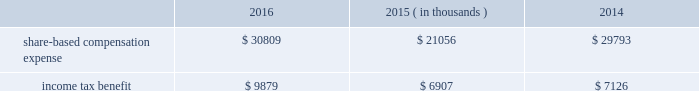2000 non-employee director stock option plan ( the 201cdirector stock option plan 201d ) , and the global payments inc .
2011 incentive plan ( the 201c2011 plan 201d ) ( collectively , the 201cplans 201d ) .
We made no further grants under the 2000 plan after the 2005 plan was effective , and the director stock option plan expired by its terms on february 1 , 2011 .
We will make no future grants under the 2000 plan , the 2005 plan or the director stock option plan .
The 2011 plan permits grants of equity to employees , officers , directors and consultants .
A total of 14.0 million shares of our common stock was reserved and made available for issuance pursuant to awards granted under the 2011 plan .
The table summarizes share-based compensation expense and the related income tax benefit recognized for our share-based awards and stock options ( in thousands ) : 2016 2015 2014 ( in thousands ) .
We grant various share-based awards pursuant to the plans under what we refer to as our 201clong-term incentive plan . 201d the awards are held in escrow and released upon the grantee 2019s satisfaction of conditions of the award certificate .
Restricted stock restricted stock awards vest over a period of time , provided , however , that if the grantee is not employed by us on the vesting date , the shares are forfeited .
Restricted shares cannot be sold or transferred until they have vested .
Restricted stock granted before fiscal 2015 vests in equal installments on each of the first four anniversaries of the grant date .
Restricted stock granted during fiscal 2015 and thereafter either vest in equal installments on each of the first three anniversaries of the grant date or cliff vest at the end of a three-year service period .
The grant date fair value of restricted stock , which is based on the quoted market value of our common stock at the closing of the award date , is recognized as share-based compensation expense on a straight-line basis over the vesting period .
Performance units certain of our executives have been granted performance units under our long-term incentive plan .
Performance units are performance-based restricted stock units that , after a performance period , convert into common shares , which may be restricted .
The number of shares is dependent upon the achievement of certain performance measures during the performance period .
The target number of performance units and any market-based performance measures ( 201cat threshold , 201d 201ctarget , 201d and 201cmaximum 201d ) are set by the compensation committee of our board of directors .
Performance units are converted only after the compensation committee certifies performance based on pre-established goals .
The performance units granted to certain executives in fiscal 2014 were based on a one-year performance period .
After the compensation committee certified the performance results , 25% ( 25 % ) of the performance units converted to unrestricted shares .
The remaining 75% ( 75 % ) converted to restricted shares that vest in equal installments on each of the first three anniversaries of the conversion date .
The performance units granted to certain executives during fiscal 2015 and fiscal 2016 were based on a three-year performance period .
After the compensation committee certifies the performance results for the three-year period , performance units earned will convert into unrestricted common stock .
The compensation committee may set a range of possible performance-based outcomes for performance units .
Depending on the achievement of the performance measures , the grantee may earn up to 200% ( 200 % ) of the target number of shares .
For awards with only performance conditions , we recognize compensation expense on a straight-line basis over the performance period using the grant date fair value of the award , which is based on the number of shares expected to be earned according to the level of achievement of performance goals .
If the number of shares expected to be earned were to change at any time during the performance period , we would make a cumulative adjustment to share-based compensation expense based on the revised number of shares expected to be earned .
Global payments inc .
| 2016 form 10-k annual report 2013 83 .
What is the estimated effective tax rate applied for share-based compensation expense in 2015? 
Computations: (6907 / 21056)
Answer: 0.32803. 